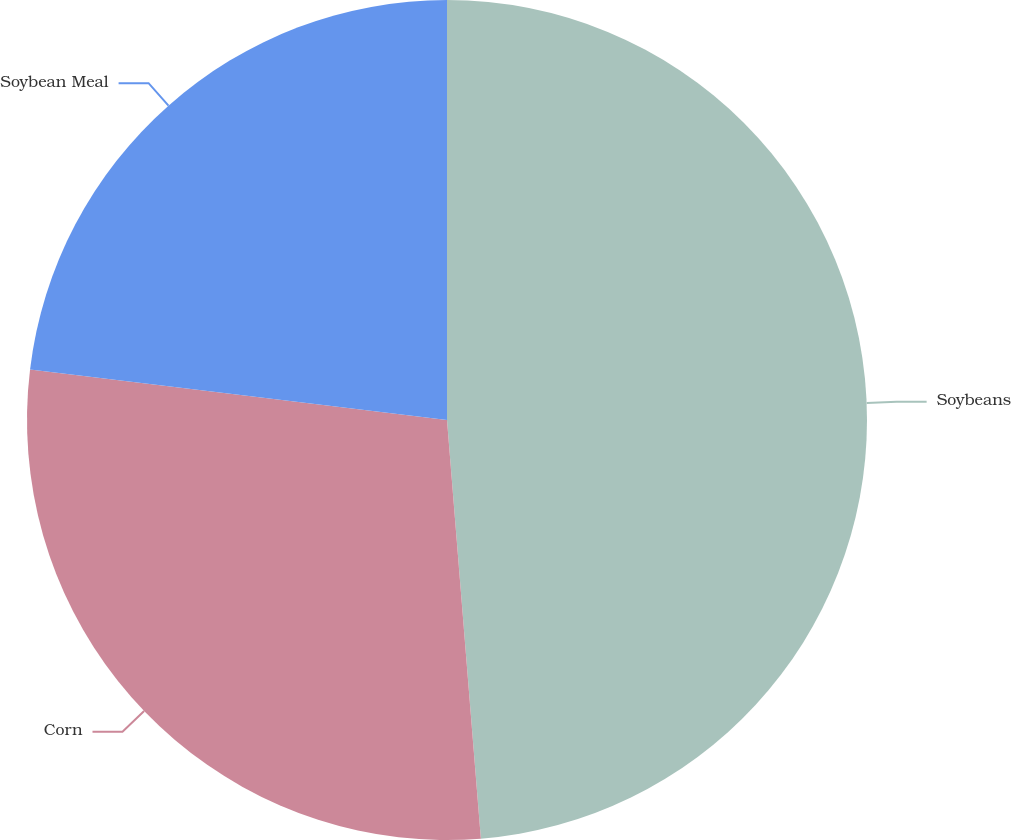<chart> <loc_0><loc_0><loc_500><loc_500><pie_chart><fcel>Soybeans<fcel>Corn<fcel>Soybean Meal<nl><fcel>48.72%<fcel>28.21%<fcel>23.08%<nl></chart> 